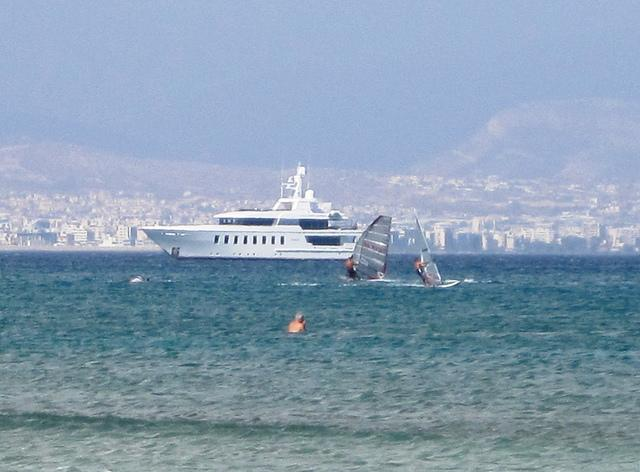How many people are holding onto parasail and sailing into the ocean? two 